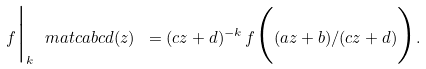<formula> <loc_0><loc_0><loc_500><loc_500>f \Big | _ { k } \ m a t c a b c d ( z ) \ = ( c z + d ) ^ { - k } \, f \Big ( ( a z + b ) / ( c z + d ) \Big ) .</formula> 